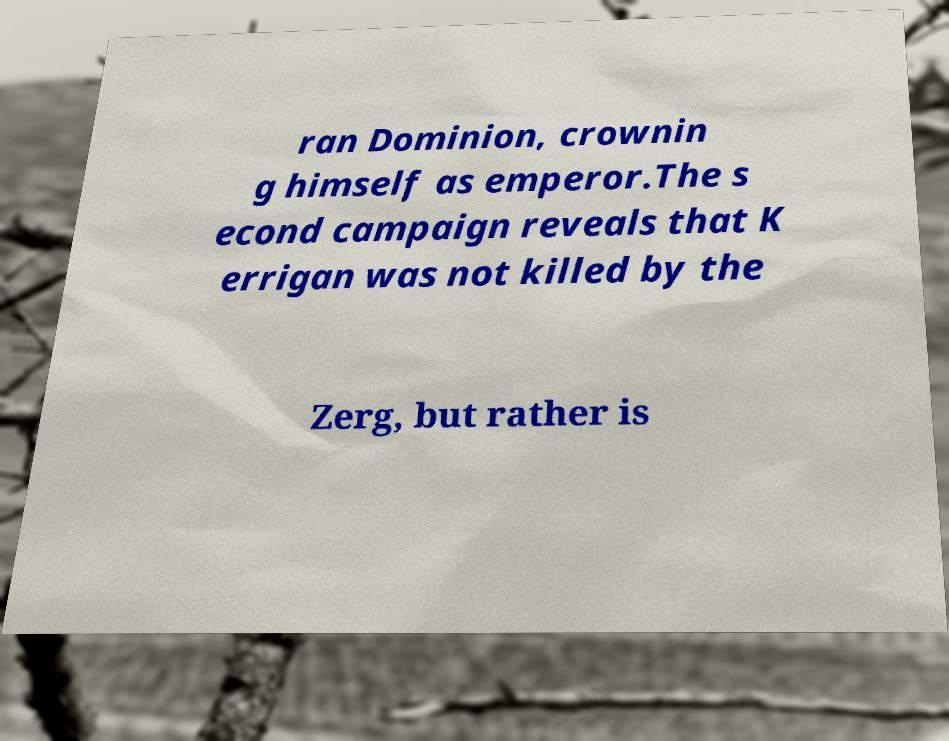Can you read and provide the text displayed in the image?This photo seems to have some interesting text. Can you extract and type it out for me? ran Dominion, crownin g himself as emperor.The s econd campaign reveals that K errigan was not killed by the Zerg, but rather is 